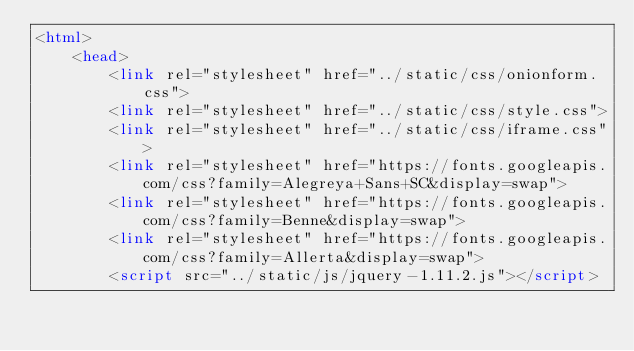<code> <loc_0><loc_0><loc_500><loc_500><_HTML_><html>
    <head>
        <link rel="stylesheet" href="../static/css/onionform.css">
        <link rel="stylesheet" href="../static/css/style.css">
        <link rel="stylesheet" href="../static/css/iframe.css"> 
        <link rel="stylesheet" href="https://fonts.googleapis.com/css?family=Alegreya+Sans+SC&display=swap">
        <link rel="stylesheet" href="https://fonts.googleapis.com/css?family=Benne&display=swap">
        <link rel="stylesheet" href="https://fonts.googleapis.com/css?family=Allerta&display=swap">
        <script src="../static/js/jquery-1.11.2.js"></script></code> 